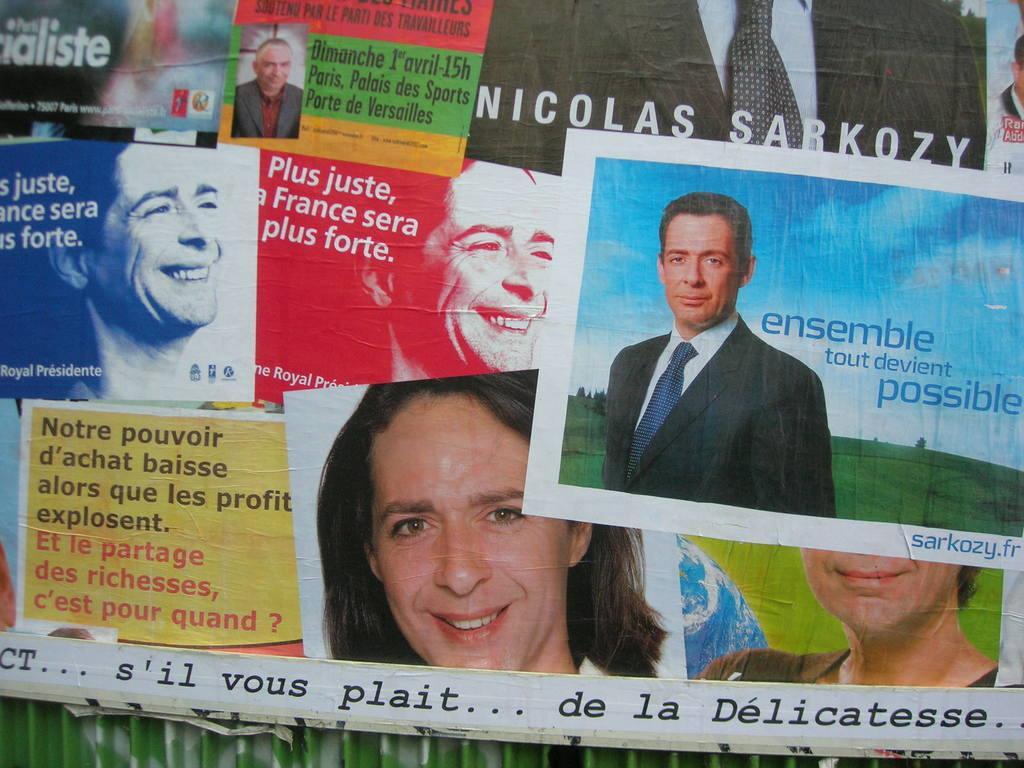In one or two sentences, can you explain what this image depicts? In the image we can see there are many posters, in each poster there is a person wearing clothes and some of them are smiling. This is a text. 